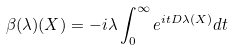<formula> <loc_0><loc_0><loc_500><loc_500>\beta ( \lambda ) ( X ) = - i \lambda \int ^ { \infty } _ { 0 } e ^ { i t D \lambda ( X ) } d t</formula> 